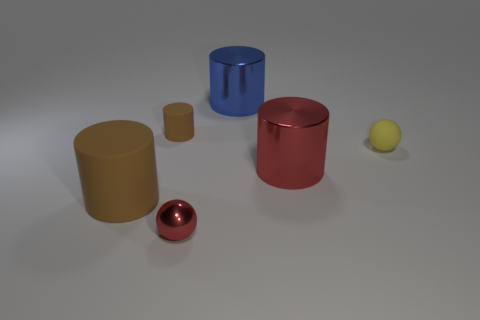Subtract all red metallic cylinders. How many cylinders are left? 3 Add 2 small gray metal cubes. How many objects exist? 8 Subtract all yellow spheres. How many spheres are left? 1 Subtract 2 spheres. How many spheres are left? 0 Subtract all spheres. How many objects are left? 4 Subtract all gray blocks. How many brown cylinders are left? 2 Add 3 big cyan rubber cylinders. How many big cyan rubber cylinders exist? 3 Subtract 0 purple cylinders. How many objects are left? 6 Subtract all yellow cylinders. Subtract all cyan blocks. How many cylinders are left? 4 Subtract all tiny cylinders. Subtract all tiny red spheres. How many objects are left? 4 